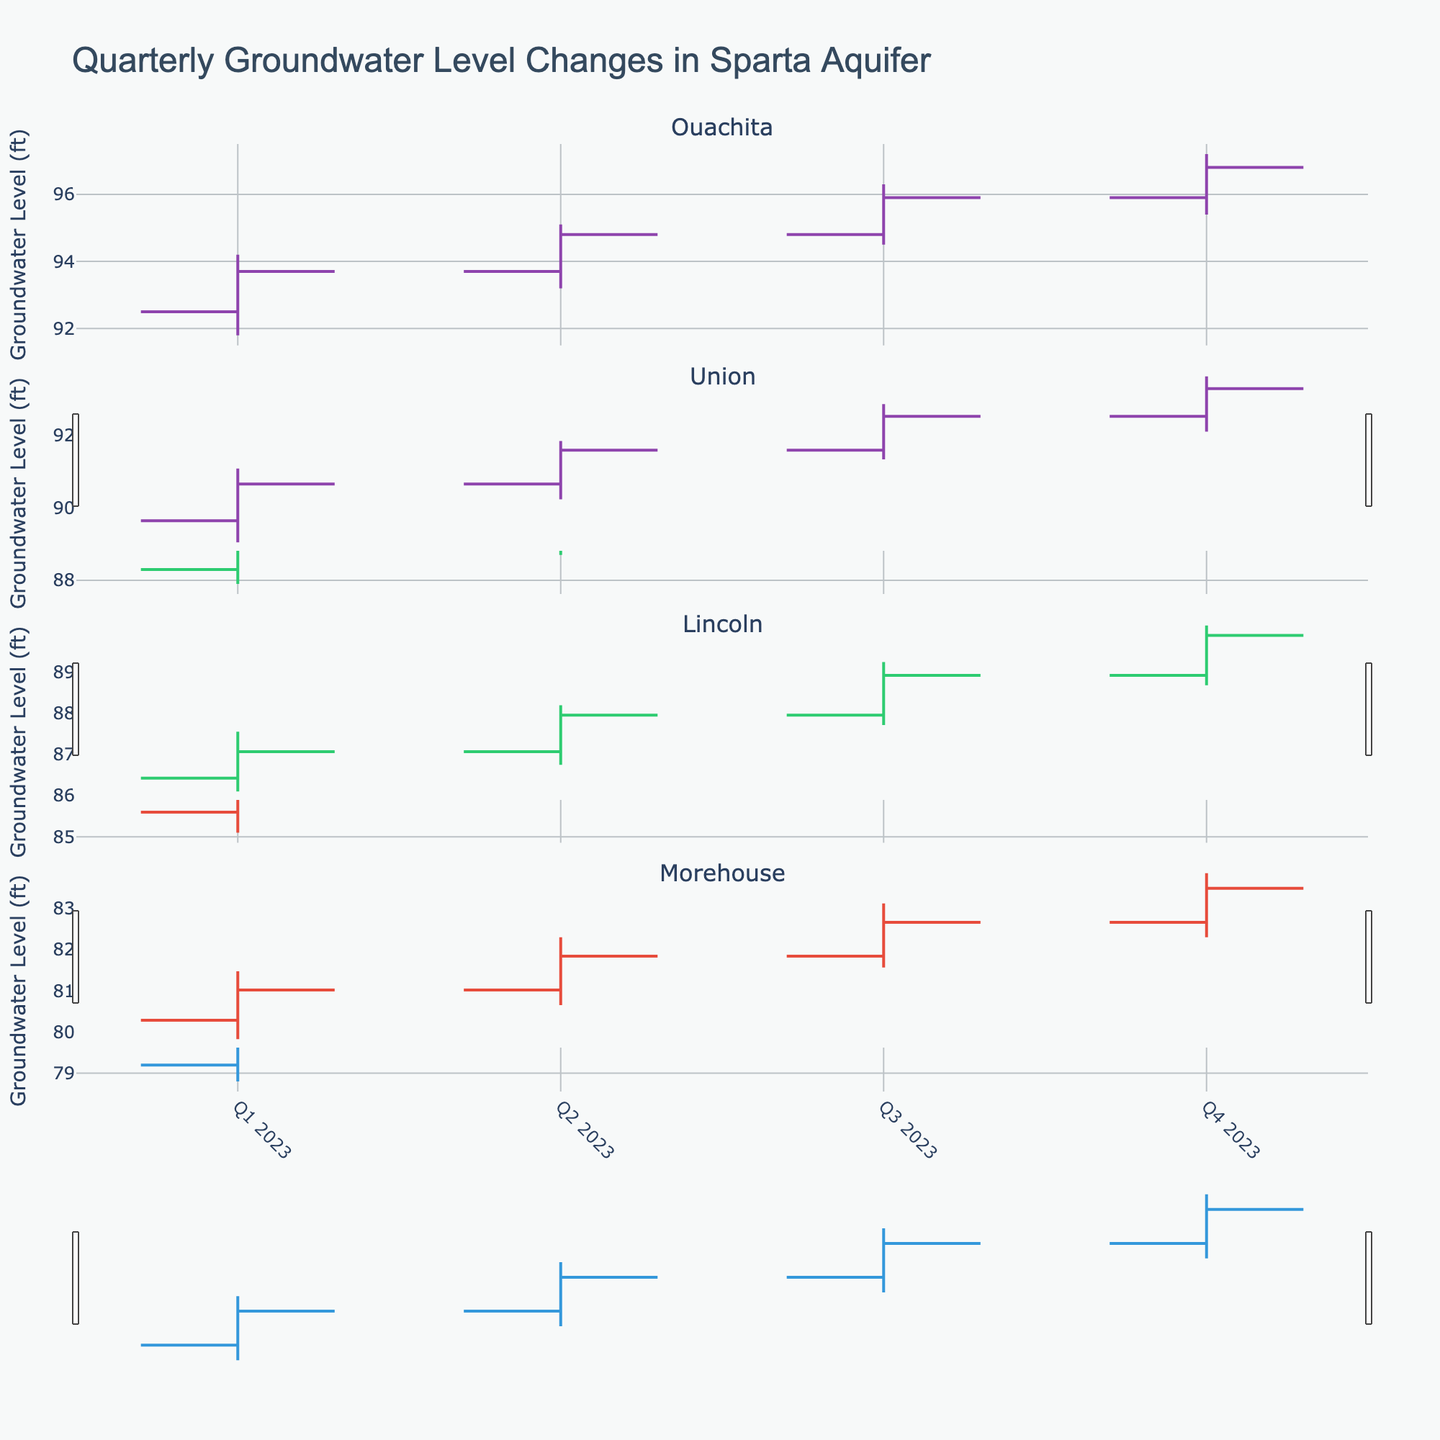Which parish shows the highest groundwater level in Q2 2023? Check the highest value (High) for each parish in Q2 2023. Ouachita has the highest value at 95.1 ft.
Answer: Ouachita What was the difference in the closing groundwater level between Q1 and Q2 2023 for Lincoln Parish? Subtract the closing level in Q1 2023 (86.4 ft) from the closing level in Q2 2023 (87.3 ft) for Lincoln Parish.
Answer: 0.9 ft How did the groundwater level for Morehouse Parish change from Q1 to Q4 2023? Compare the opening level in Q1 2023 (79.2 ft) to the closing level in Q4 2023 (82.8 ft). It increased by (82.8 - 79.2) = 3.6 ft.
Answer: Increased by 3.6 ft Which quarter had the highest closing groundwater level for Union Parish? Identify the highest closing value for Union Parish across all quarters. Q4 2023 has the highest closing level at 92.6 ft.
Answer: Q4 2023 Did the groundwater level for any parish decrease from Q1 to Q2 2023? Compare the closing levels from Q1 to Q2 2023 for each parish. All parishes show an increase in the closing levels.
Answer: No What is the average of the lowest groundwater levels recorded in 2023 across all parishes? Sum the Low values for each quarter across all parishes and divide by the number of data points (16). (91.8 + 93.2 + 94.5 + 95.4 + 87.9 + 88.7 + 89.9 + 91.1 + 85.1 + 86.0 + 87.0 + 87.8 + 78.8 + 79.7 + 80.6 + 81.5) / 16 = 88.99 ft
Answer: 88.99 ft Which parish had the smallest range (High - Low) in Q3 2023? Calculate the range (High - Low) for each parish in Q3 2023. Compare the ranges: Ouachita (1.8), Union (1.9), Lincoln (1.7), Morehouse (1.7). Both Lincoln and Morehouse have the smallest range of 1.7.
Answer: Lincoln and Morehouse What trend is observed in the groundwater level for Ouachita Parish throughout 2023? Observe the sequence of closing values for each quarter: 93.7, 94.8, 95.9, 96.8. The groundwater level shows an increasing trend.
Answer: Increasing trend What is the difference between the highest groundwater levels recorded in Q1 and Q4 2023 for all parishes? Identify the highest values for each parish in Q1 and Q4 2023. Sum the Q1 highs (94.2 + 89.7 + 86.9 + 80.5) = 351.3 and Q4 highs (97.2 + 92.9 + 89.5 + 83.2) = 362.8, then find the difference (362.8 - 351.3) = 11.5.
Answer: 11.5 